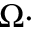Convert formula to latex. <formula><loc_0><loc_0><loc_500><loc_500>\Omega \cdot</formula> 